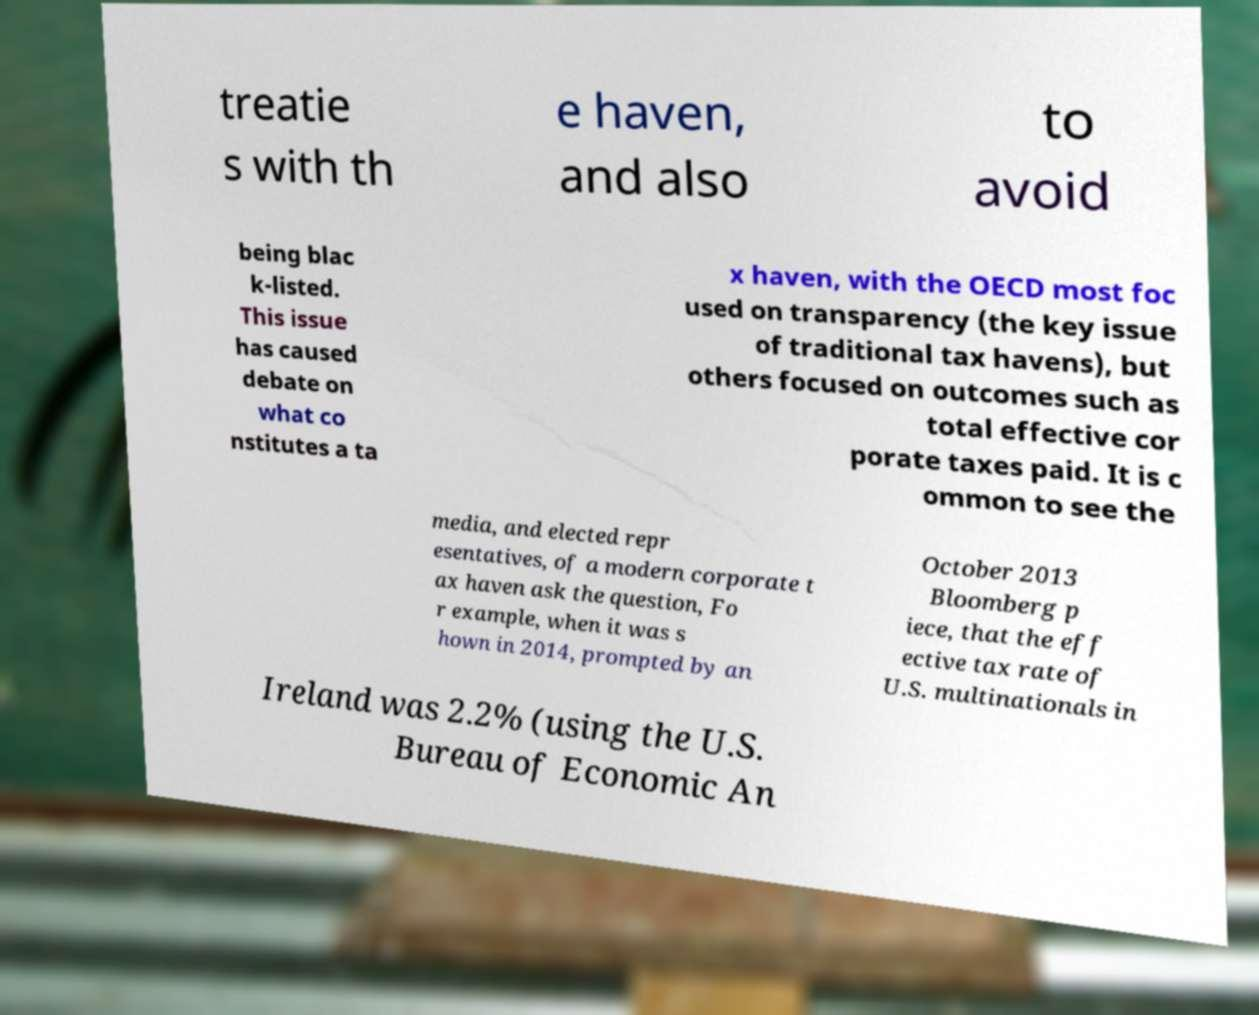Could you assist in decoding the text presented in this image and type it out clearly? treatie s with th e haven, and also to avoid being blac k-listed. This issue has caused debate on what co nstitutes a ta x haven, with the OECD most foc used on transparency (the key issue of traditional tax havens), but others focused on outcomes such as total effective cor porate taxes paid. It is c ommon to see the media, and elected repr esentatives, of a modern corporate t ax haven ask the question, Fo r example, when it was s hown in 2014, prompted by an October 2013 Bloomberg p iece, that the eff ective tax rate of U.S. multinationals in Ireland was 2.2% (using the U.S. Bureau of Economic An 